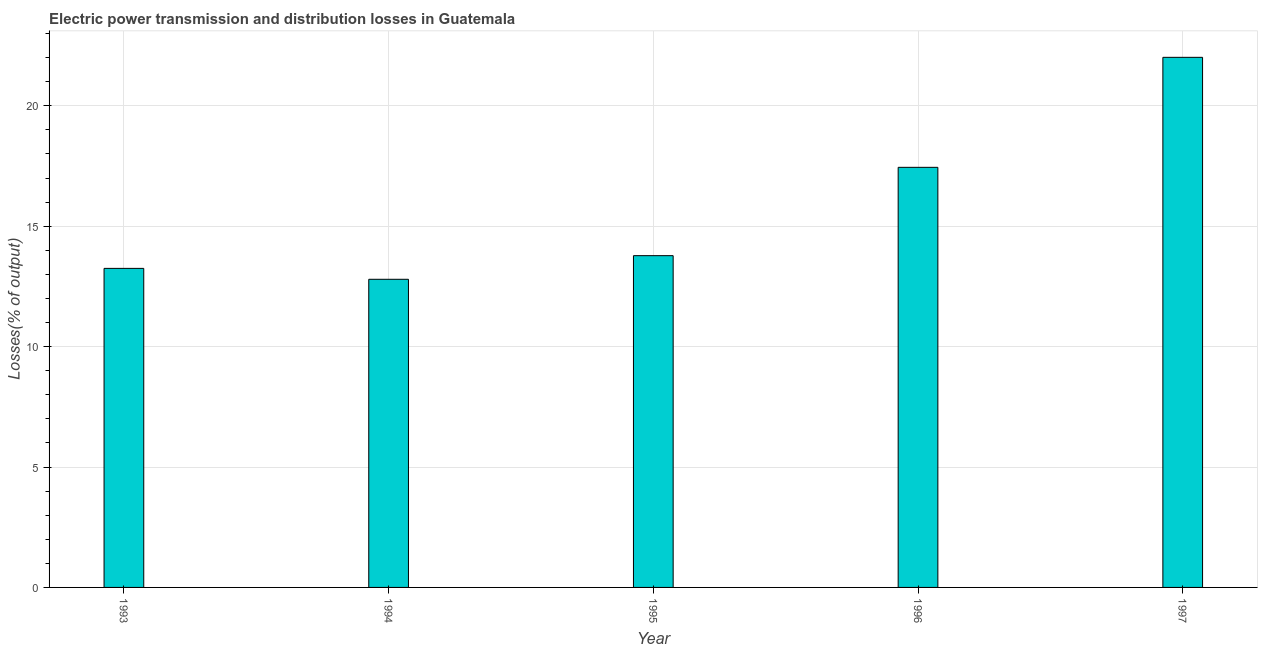Does the graph contain any zero values?
Provide a succinct answer. No. Does the graph contain grids?
Offer a very short reply. Yes. What is the title of the graph?
Your response must be concise. Electric power transmission and distribution losses in Guatemala. What is the label or title of the X-axis?
Offer a very short reply. Year. What is the label or title of the Y-axis?
Give a very brief answer. Losses(% of output). What is the electric power transmission and distribution losses in 1993?
Your response must be concise. 13.25. Across all years, what is the maximum electric power transmission and distribution losses?
Your answer should be very brief. 22.01. Across all years, what is the minimum electric power transmission and distribution losses?
Your answer should be very brief. 12.79. In which year was the electric power transmission and distribution losses minimum?
Provide a short and direct response. 1994. What is the sum of the electric power transmission and distribution losses?
Your answer should be compact. 79.27. What is the difference between the electric power transmission and distribution losses in 1995 and 1996?
Provide a succinct answer. -3.67. What is the average electric power transmission and distribution losses per year?
Your response must be concise. 15.85. What is the median electric power transmission and distribution losses?
Offer a terse response. 13.78. Do a majority of the years between 1993 and 1997 (inclusive) have electric power transmission and distribution losses greater than 14 %?
Give a very brief answer. No. Is the difference between the electric power transmission and distribution losses in 1996 and 1997 greater than the difference between any two years?
Offer a very short reply. No. What is the difference between the highest and the second highest electric power transmission and distribution losses?
Give a very brief answer. 4.57. Is the sum of the electric power transmission and distribution losses in 1994 and 1997 greater than the maximum electric power transmission and distribution losses across all years?
Your answer should be very brief. Yes. What is the difference between the highest and the lowest electric power transmission and distribution losses?
Provide a succinct answer. 9.22. How many bars are there?
Provide a short and direct response. 5. Are all the bars in the graph horizontal?
Your answer should be compact. No. What is the difference between two consecutive major ticks on the Y-axis?
Give a very brief answer. 5. What is the Losses(% of output) in 1993?
Ensure brevity in your answer.  13.25. What is the Losses(% of output) in 1994?
Your answer should be very brief. 12.79. What is the Losses(% of output) of 1995?
Offer a terse response. 13.78. What is the Losses(% of output) of 1996?
Make the answer very short. 17.44. What is the Losses(% of output) of 1997?
Provide a short and direct response. 22.01. What is the difference between the Losses(% of output) in 1993 and 1994?
Offer a very short reply. 0.45. What is the difference between the Losses(% of output) in 1993 and 1995?
Ensure brevity in your answer.  -0.53. What is the difference between the Losses(% of output) in 1993 and 1996?
Your response must be concise. -4.2. What is the difference between the Losses(% of output) in 1993 and 1997?
Offer a terse response. -8.76. What is the difference between the Losses(% of output) in 1994 and 1995?
Your answer should be very brief. -0.98. What is the difference between the Losses(% of output) in 1994 and 1996?
Give a very brief answer. -4.65. What is the difference between the Losses(% of output) in 1994 and 1997?
Your response must be concise. -9.22. What is the difference between the Losses(% of output) in 1995 and 1996?
Your answer should be compact. -3.67. What is the difference between the Losses(% of output) in 1995 and 1997?
Offer a very short reply. -8.24. What is the difference between the Losses(% of output) in 1996 and 1997?
Provide a short and direct response. -4.57. What is the ratio of the Losses(% of output) in 1993 to that in 1994?
Your response must be concise. 1.03. What is the ratio of the Losses(% of output) in 1993 to that in 1995?
Your answer should be compact. 0.96. What is the ratio of the Losses(% of output) in 1993 to that in 1996?
Offer a terse response. 0.76. What is the ratio of the Losses(% of output) in 1993 to that in 1997?
Your answer should be very brief. 0.6. What is the ratio of the Losses(% of output) in 1994 to that in 1995?
Your answer should be very brief. 0.93. What is the ratio of the Losses(% of output) in 1994 to that in 1996?
Provide a short and direct response. 0.73. What is the ratio of the Losses(% of output) in 1994 to that in 1997?
Provide a short and direct response. 0.58. What is the ratio of the Losses(% of output) in 1995 to that in 1996?
Your answer should be very brief. 0.79. What is the ratio of the Losses(% of output) in 1995 to that in 1997?
Your answer should be compact. 0.63. What is the ratio of the Losses(% of output) in 1996 to that in 1997?
Offer a terse response. 0.79. 